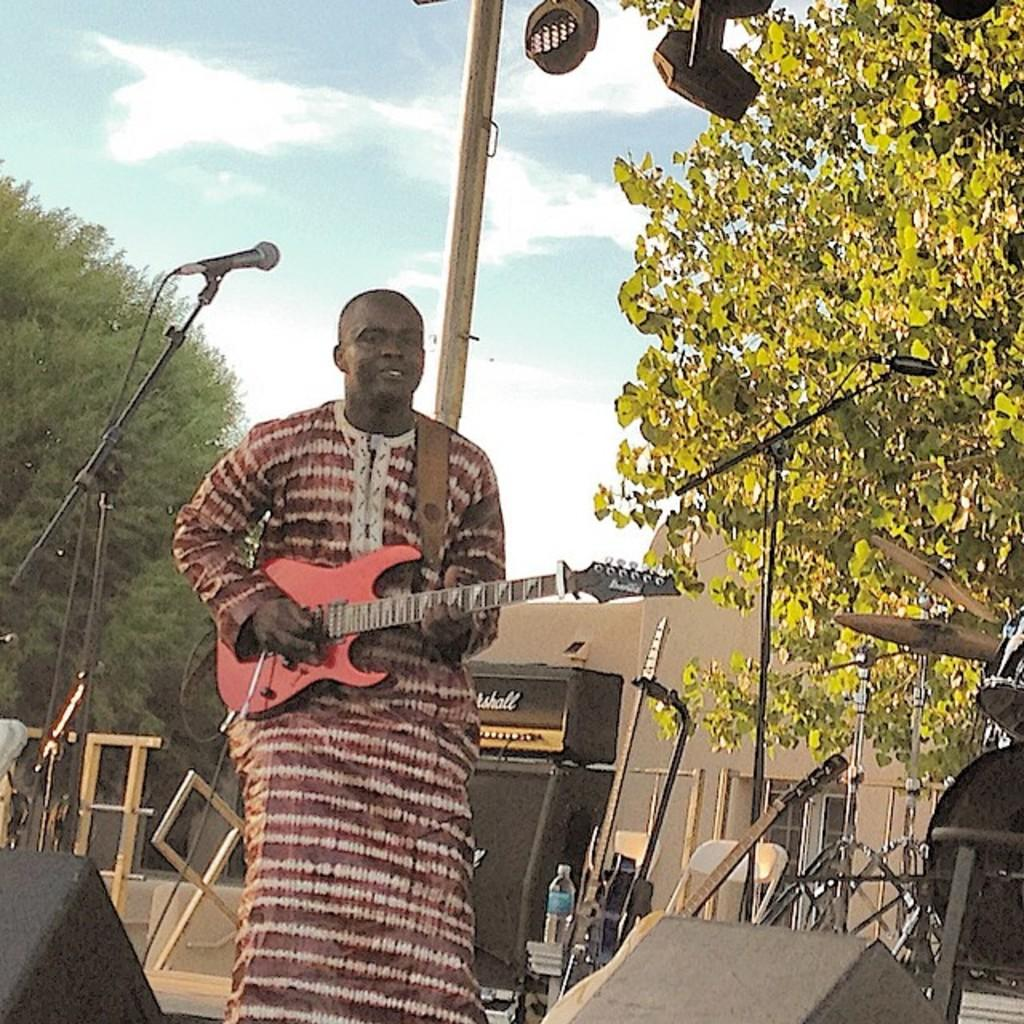What is the man in the image holding? The man is holding a guitar. What object is present in the image that is typically used for amplifying sound? There is a microphone in the image. What can be seen in the background of the image? There is a building and a tree in the background of the image. What type of thread is the man using to play the guitar in the image? There is no thread present in the image, and the man is not using any thread to play the guitar. How does the chicken in the image contribute to the man's musical performance? There is no chicken present in the image, so it cannot contribute to the man's musical performance. 